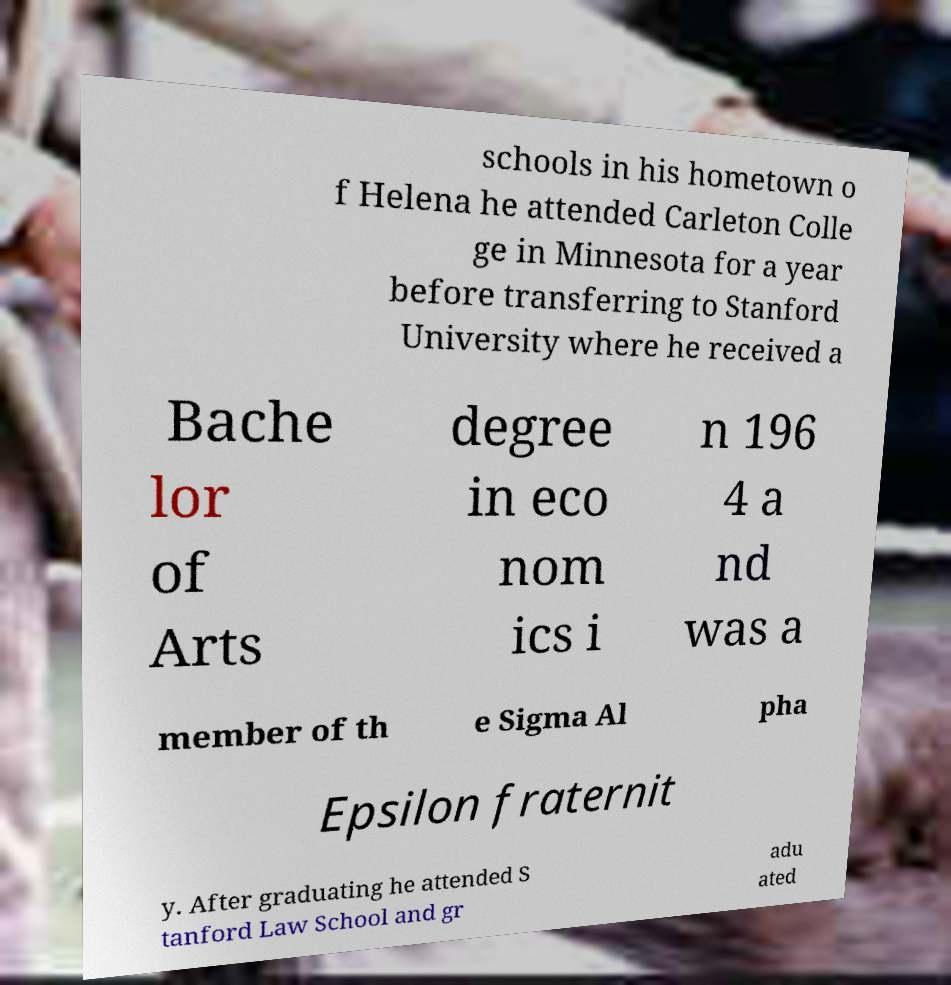There's text embedded in this image that I need extracted. Can you transcribe it verbatim? schools in his hometown o f Helena he attended Carleton Colle ge in Minnesota for a year before transferring to Stanford University where he received a Bache lor of Arts degree in eco nom ics i n 196 4 a nd was a member of th e Sigma Al pha Epsilon fraternit y. After graduating he attended S tanford Law School and gr adu ated 